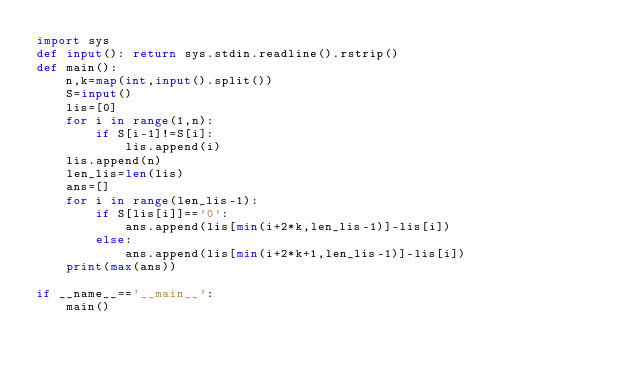<code> <loc_0><loc_0><loc_500><loc_500><_Python_>import sys
def input(): return sys.stdin.readline().rstrip()
def main():
    n,k=map(int,input().split())
    S=input()
    lis=[0]
    for i in range(1,n):
        if S[i-1]!=S[i]:
            lis.append(i)
    lis.append(n)
    len_lis=len(lis)
    ans=[]
    for i in range(len_lis-1):
        if S[lis[i]]=='0':
            ans.append(lis[min(i+2*k,len_lis-1)]-lis[i])
        else:
            ans.append(lis[min(i+2*k+1,len_lis-1)]-lis[i])
    print(max(ans))

if __name__=='__main__':
    main()</code> 